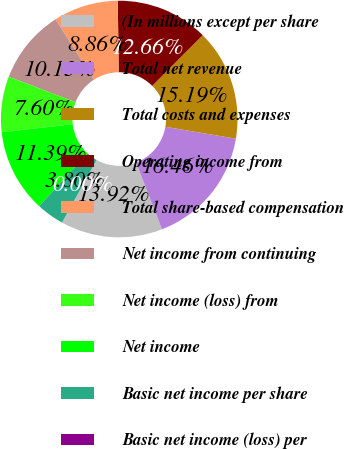Convert chart. <chart><loc_0><loc_0><loc_500><loc_500><pie_chart><fcel>(In millions except per share<fcel>Total net revenue<fcel>Total costs and expenses<fcel>Operating income from<fcel>Total share-based compensation<fcel>Net income from continuing<fcel>Net income (loss) from<fcel>Net income<fcel>Basic net income per share<fcel>Basic net income (loss) per<nl><fcel>13.92%<fcel>16.46%<fcel>15.19%<fcel>12.66%<fcel>8.86%<fcel>10.13%<fcel>7.6%<fcel>11.39%<fcel>3.8%<fcel>0.0%<nl></chart> 